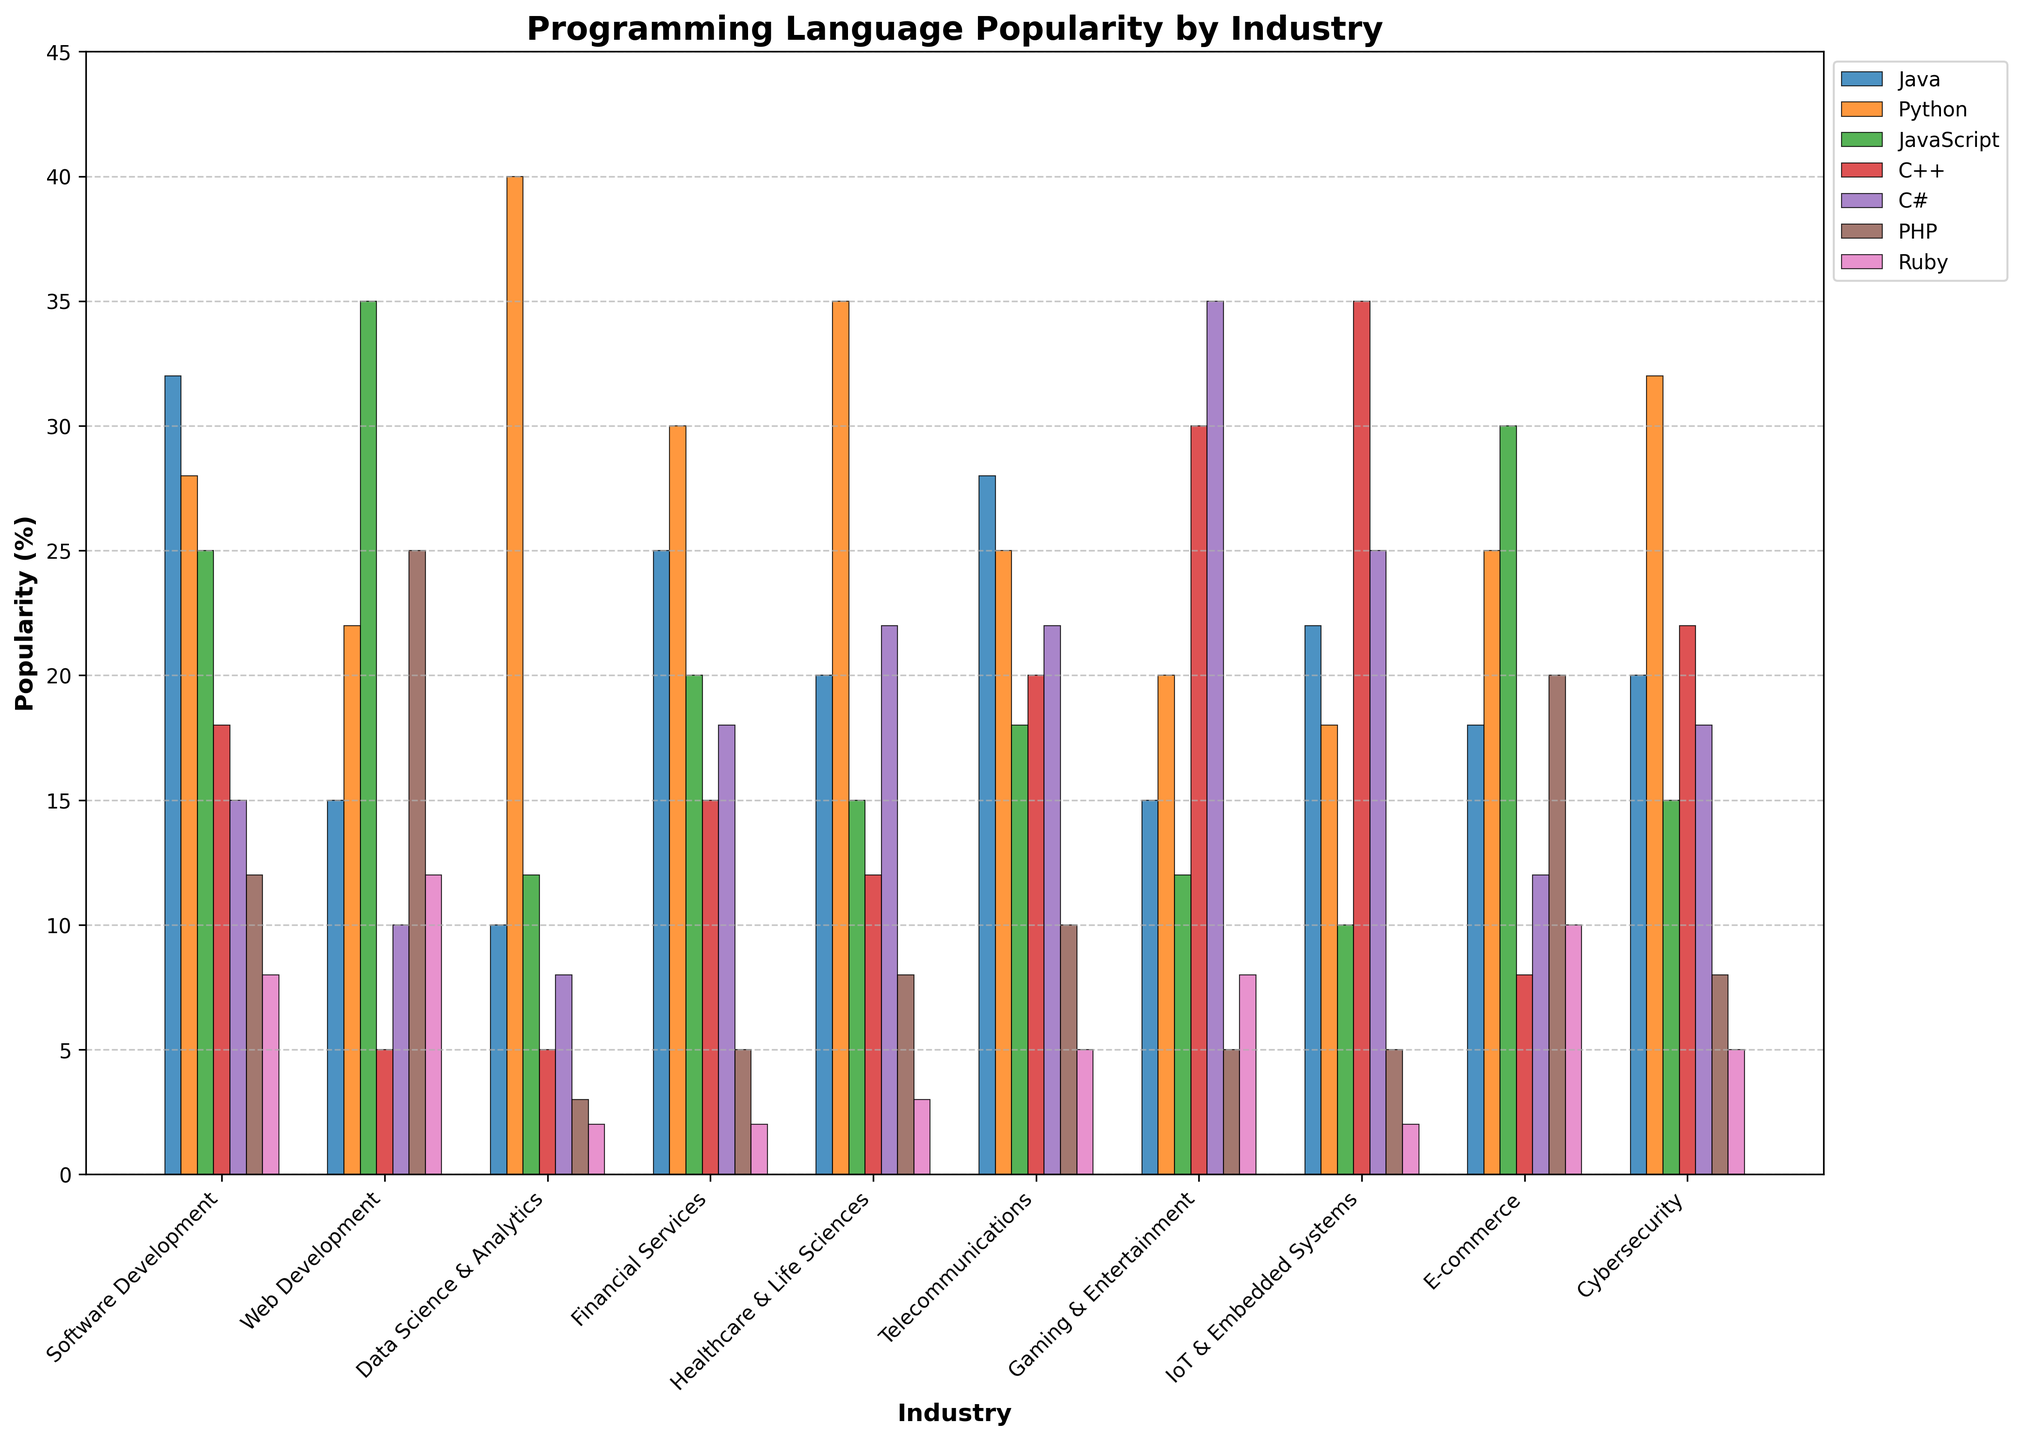Which industry uses Java the most? To find the industry that uses Java the most, we look for the tallest bar associated with Java across all industries. The software development industry has a bar with a height representing a 32% usage of Java, which is the highest among all industries for Java.
Answer: Software Development What is the combined percentage of Python usage in Financial Services and Healthcare & Life Sciences? The percentage of Python usage in Financial Services is 30%. In Healthcare & Life Sciences, it is 35%. Summing these two percentages, we get 30% + 35% = 65%.
Answer: 65% Which programming language is most popular in the Gaming & Entertainment industry? To identify the most popular programming language in the Gaming & Entertainment industry, we compare the heights of all corresponding bars. C++ has the tallest bar in this industry, representing a 30% usage, which is the highest among others.
Answer: C++ Is Python more popular in Data Science & Analytics or in Cybersecurity? Comparing the heights of the bars for Python in Data Science & Analytics and Cybersecurity, we observe that the bar for Python in Data Science & Analytics is higher, representing 40% usage, while in Cybersecurity, it represents 32% usage. Consequently, Python is more popular in Data Science & Analytics.
Answer: Data Science & Analytics Which two industries have the closest popularity percentages for JavaScript? By examining the heights of the bars for JavaScript across industries, we find that in E-commerce and Web Development, the bars are at 30% and 35%, respectively. These two values are close to each other compared to the other percentages.
Answer: E-commerce and Web Development What is the total percentage usage of C# in Telecommunications, Gaming & Entertainment, and Cybersecurity? The percentage usage of C# in Telecommunications is 22%, in Gaming & Entertainment is 35%, and in Cybersecurity is 18%. Summing these, we get 22% + 35% + 18% = 75%.
Answer: 75% Which industry shows the least popularity for PHP? To find the industry with the least popularity for PHP, we look for the shortest bar corresponding to PHP among all industries. Data Science & Analytics has the shortest bar, representing just 3% usage of PHP.
Answer: Data Science & Analytics Is Ruby more popular than C++ in Web Development? Comparing the heights of the bars for Ruby and C++ in Web Development, the bar for Ruby is higher at 12%, while the bar for C++ is at 5%. Therefore, Ruby is more popular than C++ in Web Development.
Answer: Yes What is the average popularity percentage of Java in the industries displayed? To find the average popularity, sum the percentages of Java across all industries: 32 + 15 + 10 + 25 + 20 + 28 + 15 + 22 + 18 + 20 = 205. There are 10 industries, so the average is 205 / 10 = 20.5%.
Answer: 20.5% Among the industries listed, which one has the highest combined popularity percentage for C++ and IoT & Embedded Systems? Combining the percentages of C++ and IoT & Embedded Systems across all industries, we get the data:  C++ (Software Development) = 18%; IoT & Embedded Systems (Software Development) = 35%. IoT & Embedded Systems show the highest percentage for C++ alone, but we must sum other relevant combined values: SC & IoT at 35 + 22 (57%). Comparing these sums across combinations, the highest score is for IoT & Embedded (35% + 25%) which results in 60%.
Answer: IoT & Embedded Systems 